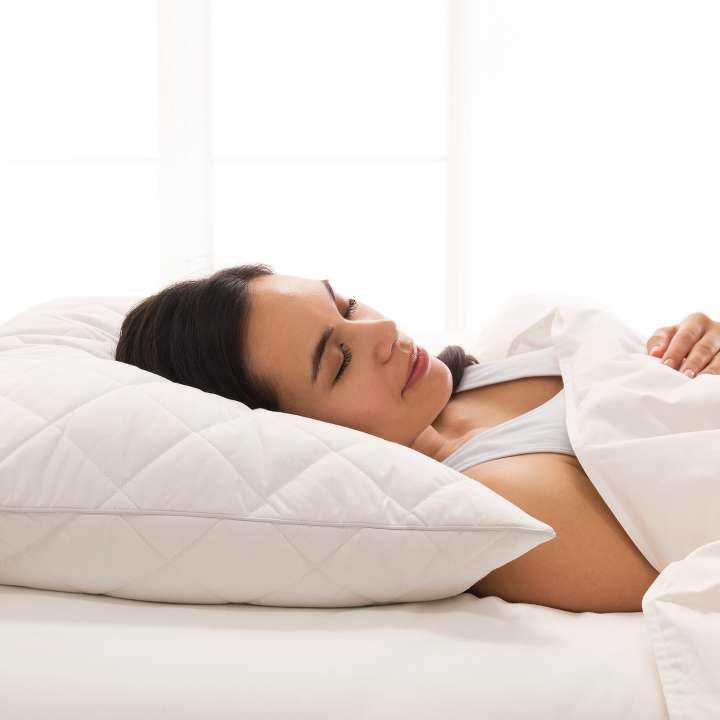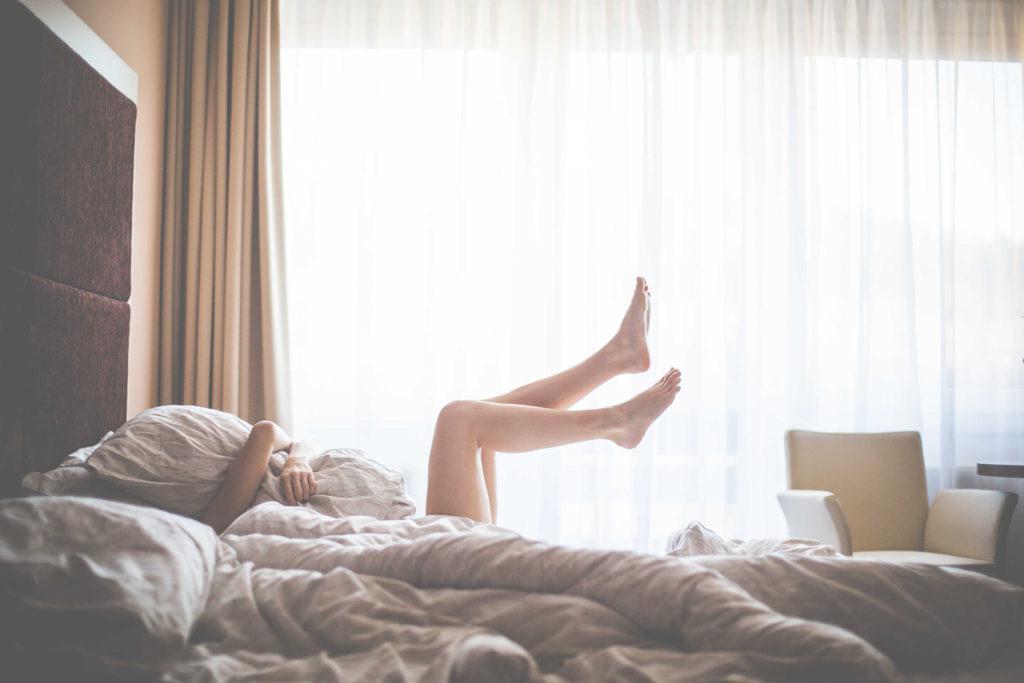The first image is the image on the left, the second image is the image on the right. Considering the images on both sides, is "An image shows a person with bare legs on a bed next to a window with a fabric drape." valid? Answer yes or no. Yes. The first image is the image on the left, the second image is the image on the right. Assess this claim about the two images: "A person is laying in the bed in the image on the left.". Correct or not? Answer yes or no. Yes. 